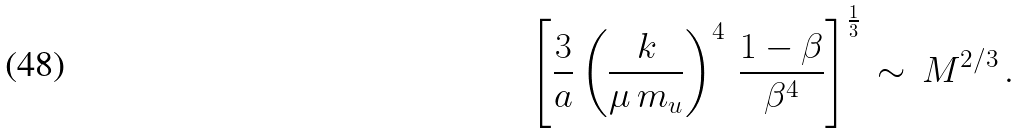<formula> <loc_0><loc_0><loc_500><loc_500>\left [ \frac { 3 } { a } \left ( \frac { k } { \mu \, m _ { u } } \right ) ^ { 4 } \, \frac { 1 - \beta } { \beta ^ { 4 } } \right ] ^ { \frac { 1 } { 3 } } \, \sim \, M ^ { 2 / 3 } \, .</formula> 